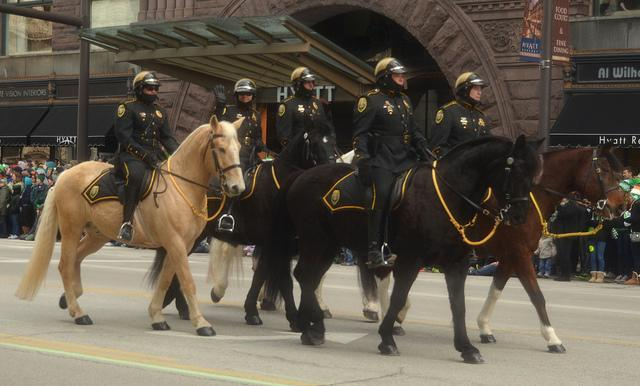What hotel is in the background behind the policemen and horses? hyatt 